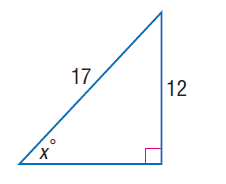Answer the mathemtical geometry problem and directly provide the correct option letter.
Question: Find x.
Choices: A: 44.9 B: 46.9 C: 57.1 D: 58.1 A 